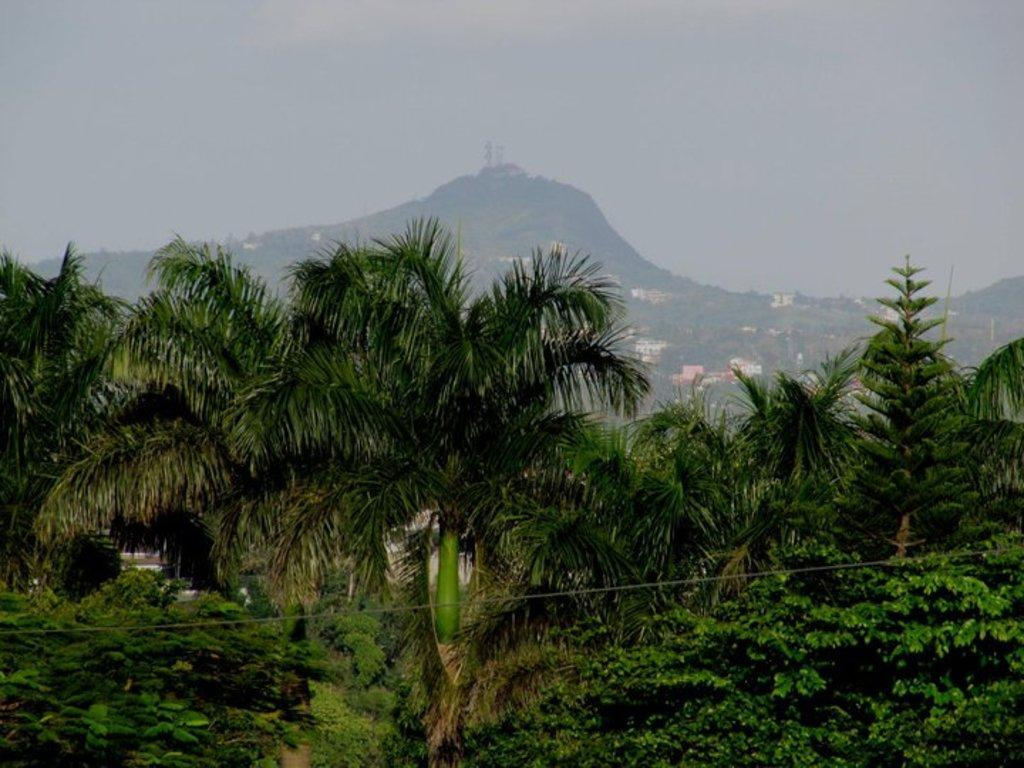What type of vegetation can be seen at the bottom of the image? There are coconut trees in the front bottom side of the image. What natural features are visible in the background of the image? There are mountains visible in the image. What type of structures can be seen in the image? There are small houses in the image. What is visible at the top of the image? The sky is visible at the top of the image. Can you tell me where the notebook is located in the image? There is no notebook present in the image. How many grapes are hanging from the coconut trees in the image? There are no grapes present in the image; it features coconut trees. 